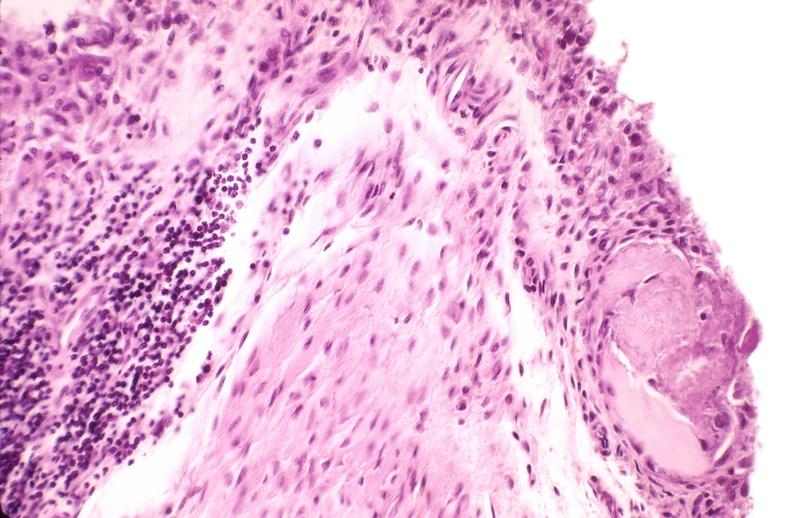what does this image show?
Answer the question using a single word or phrase. Rheumatoid arthritis 